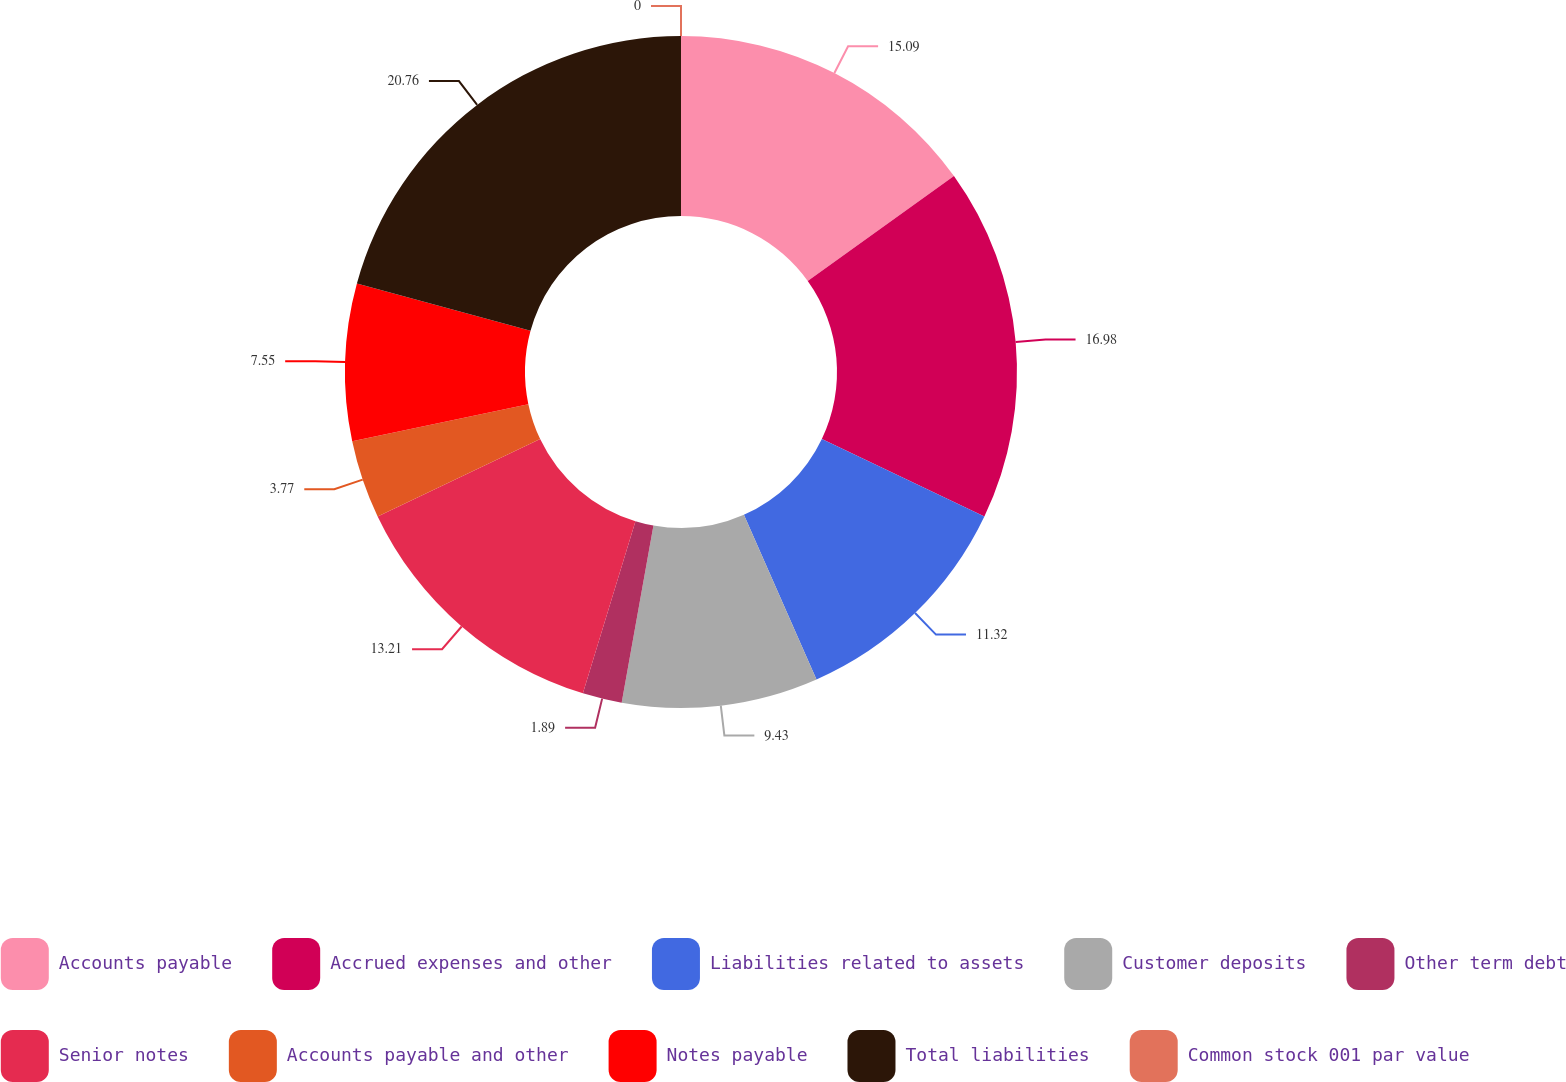<chart> <loc_0><loc_0><loc_500><loc_500><pie_chart><fcel>Accounts payable<fcel>Accrued expenses and other<fcel>Liabilities related to assets<fcel>Customer deposits<fcel>Other term debt<fcel>Senior notes<fcel>Accounts payable and other<fcel>Notes payable<fcel>Total liabilities<fcel>Common stock 001 par value<nl><fcel>15.09%<fcel>16.98%<fcel>11.32%<fcel>9.43%<fcel>1.89%<fcel>13.21%<fcel>3.77%<fcel>7.55%<fcel>20.75%<fcel>0.0%<nl></chart> 